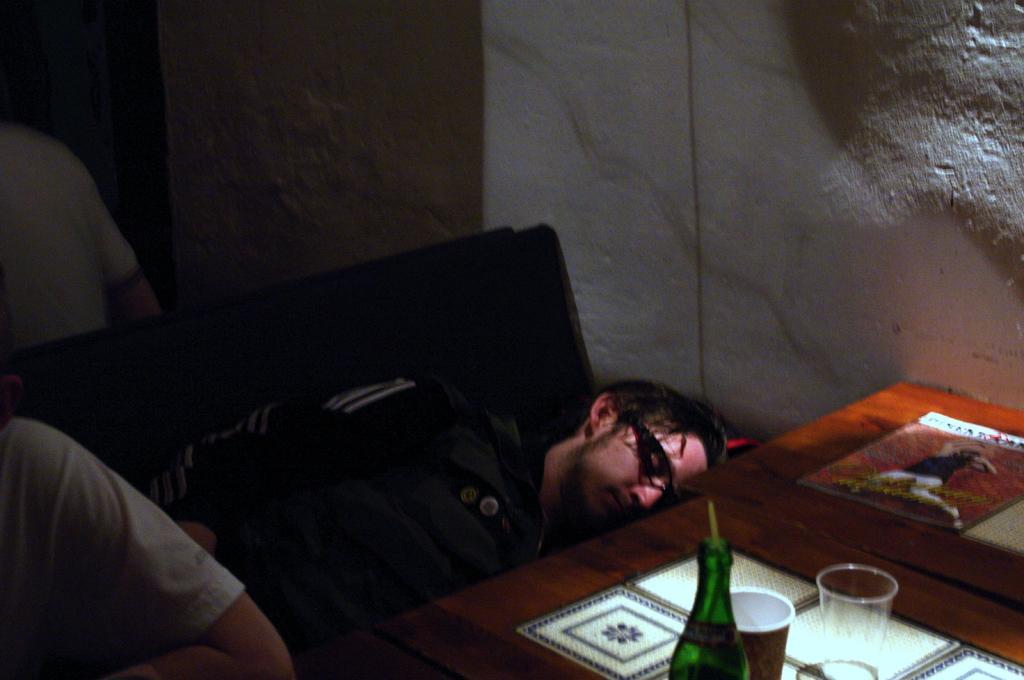Please provide a concise description of this image. In this picture we can see man sleeping and beside to him person and in front of them we have table and on table we can see glass, bottle, book and in background we can see wall. 